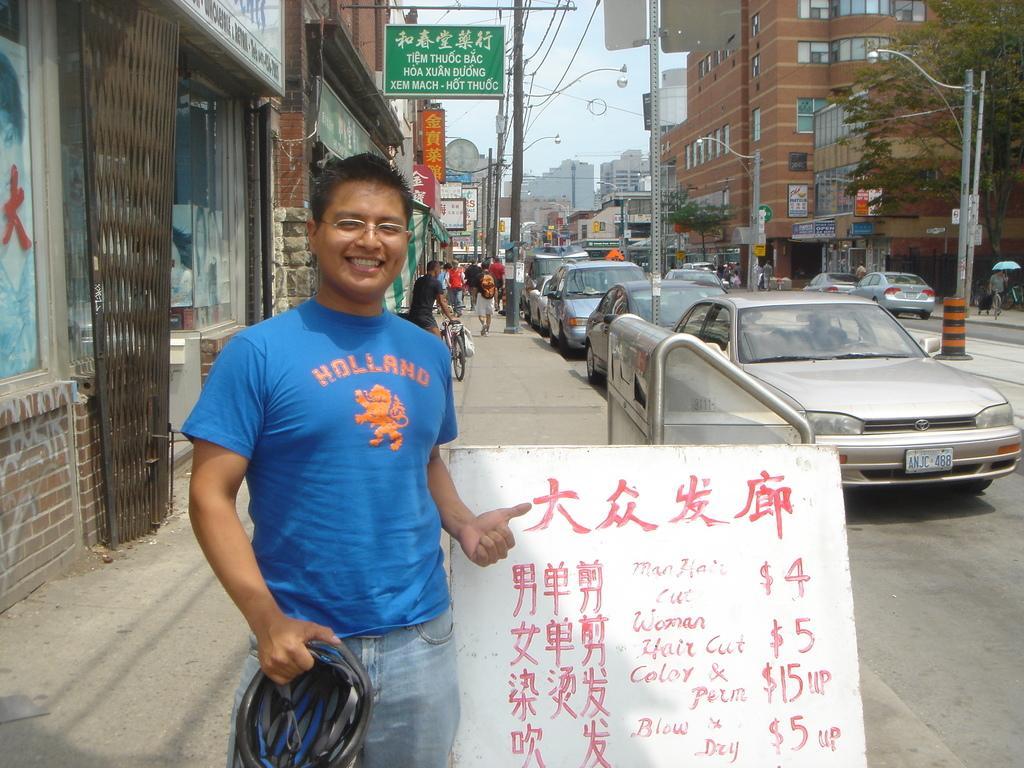Can you describe this image briefly? There is a person holding a helmet and a board on which, there is text in the foreground, there are posters, poles, vehicles, stalls, buildings and sky in the background area, there is a tree in the top right side. 